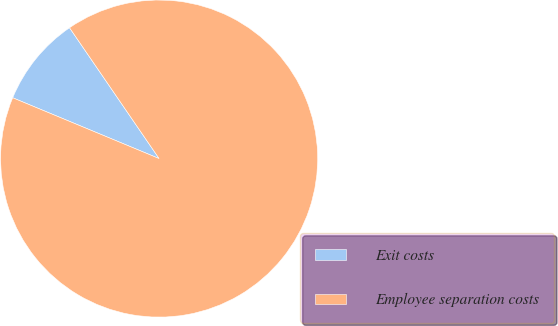Convert chart to OTSL. <chart><loc_0><loc_0><loc_500><loc_500><pie_chart><fcel>Exit costs<fcel>Employee separation costs<nl><fcel>9.18%<fcel>90.82%<nl></chart> 